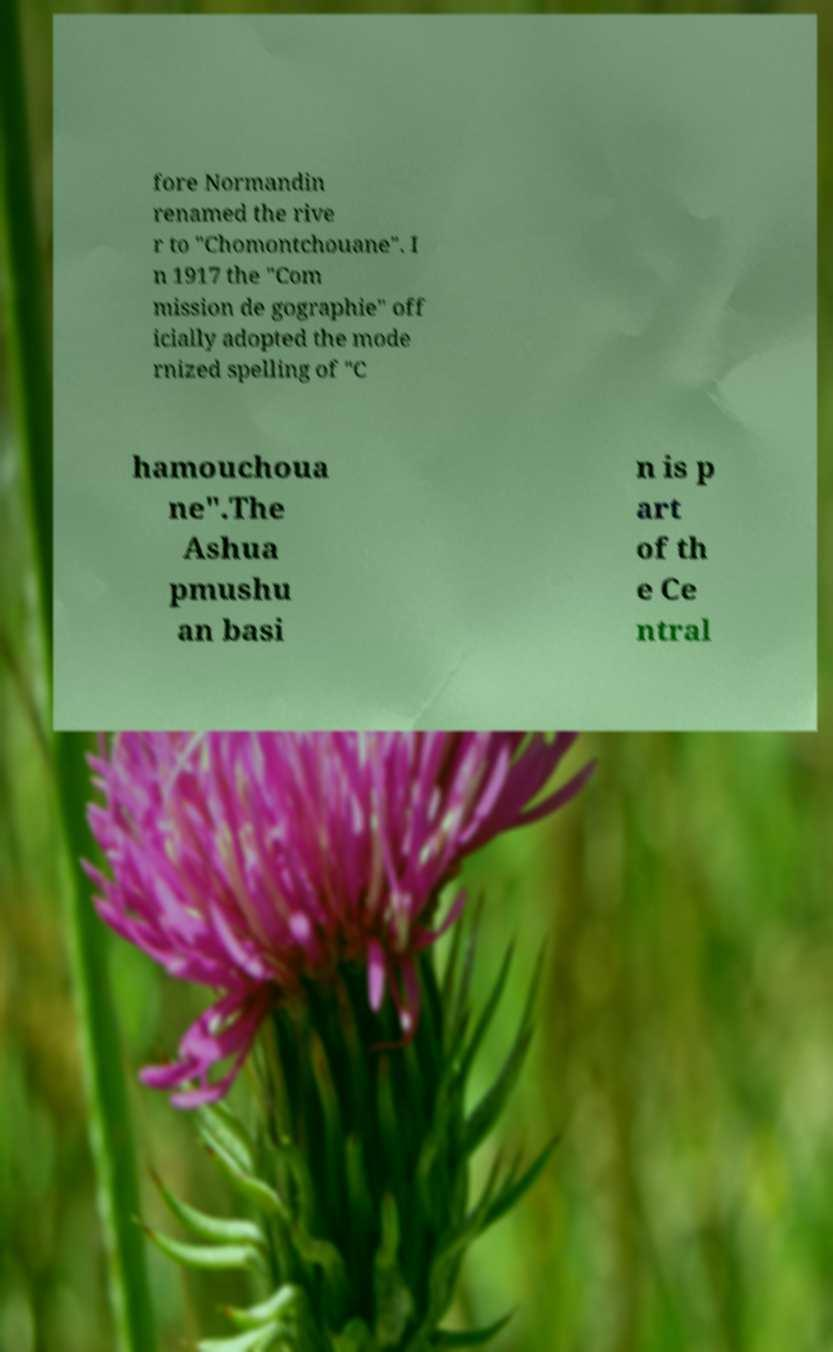Could you assist in decoding the text presented in this image and type it out clearly? fore Normandin renamed the rive r to "Chomontchouane". I n 1917 the "Com mission de gographie" off icially adopted the mode rnized spelling of "C hamouchoua ne".The Ashua pmushu an basi n is p art of th e Ce ntral 